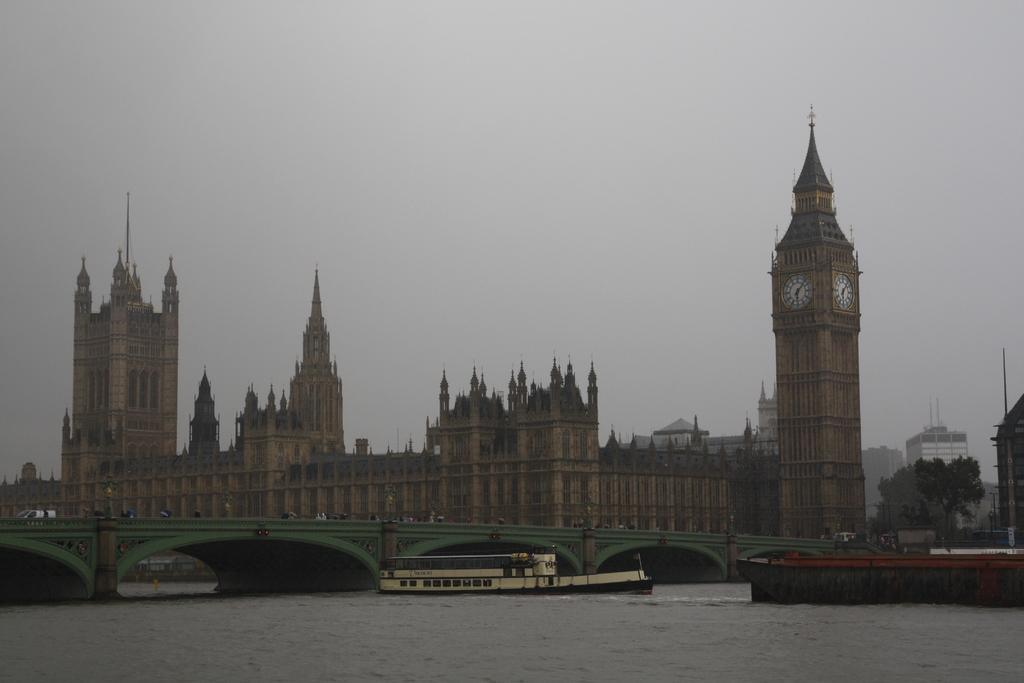What type of structures can be seen in the image? There are many buildings in the image. What time-related object is present in the image? There is a clock in the image. What mode of transportation can be seen in the image? There is a boat in the image. What natural element is present in the image? There is water in the image. What architectural feature is present in the image? There is a bridge in the image. What type of plant is present in the image? There is a tree in the image. What part of the natural environment is visible in the image? The sky is visible in the image. What are the people on the bridge doing? The people on the bridge are wearing clothes. What type of sock is visible on the bridge? There are no socks visible in the image; only people wearing clothes are present on the bridge. What type of boot can be seen in the aftermath of the storm? There is no mention of a storm or any aftermath in the image; it features a bridge, buildings, a boat, water, a tree, and the sky. 